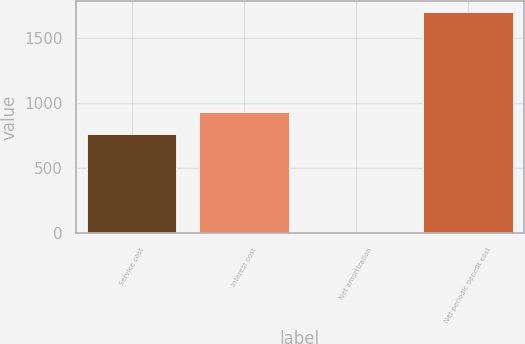Convert chart to OTSL. <chart><loc_0><loc_0><loc_500><loc_500><bar_chart><fcel>Service cost<fcel>Interest cost<fcel>Net amortization<fcel>Net periodic benefit cost<nl><fcel>763<fcel>931.5<fcel>11<fcel>1696<nl></chart> 